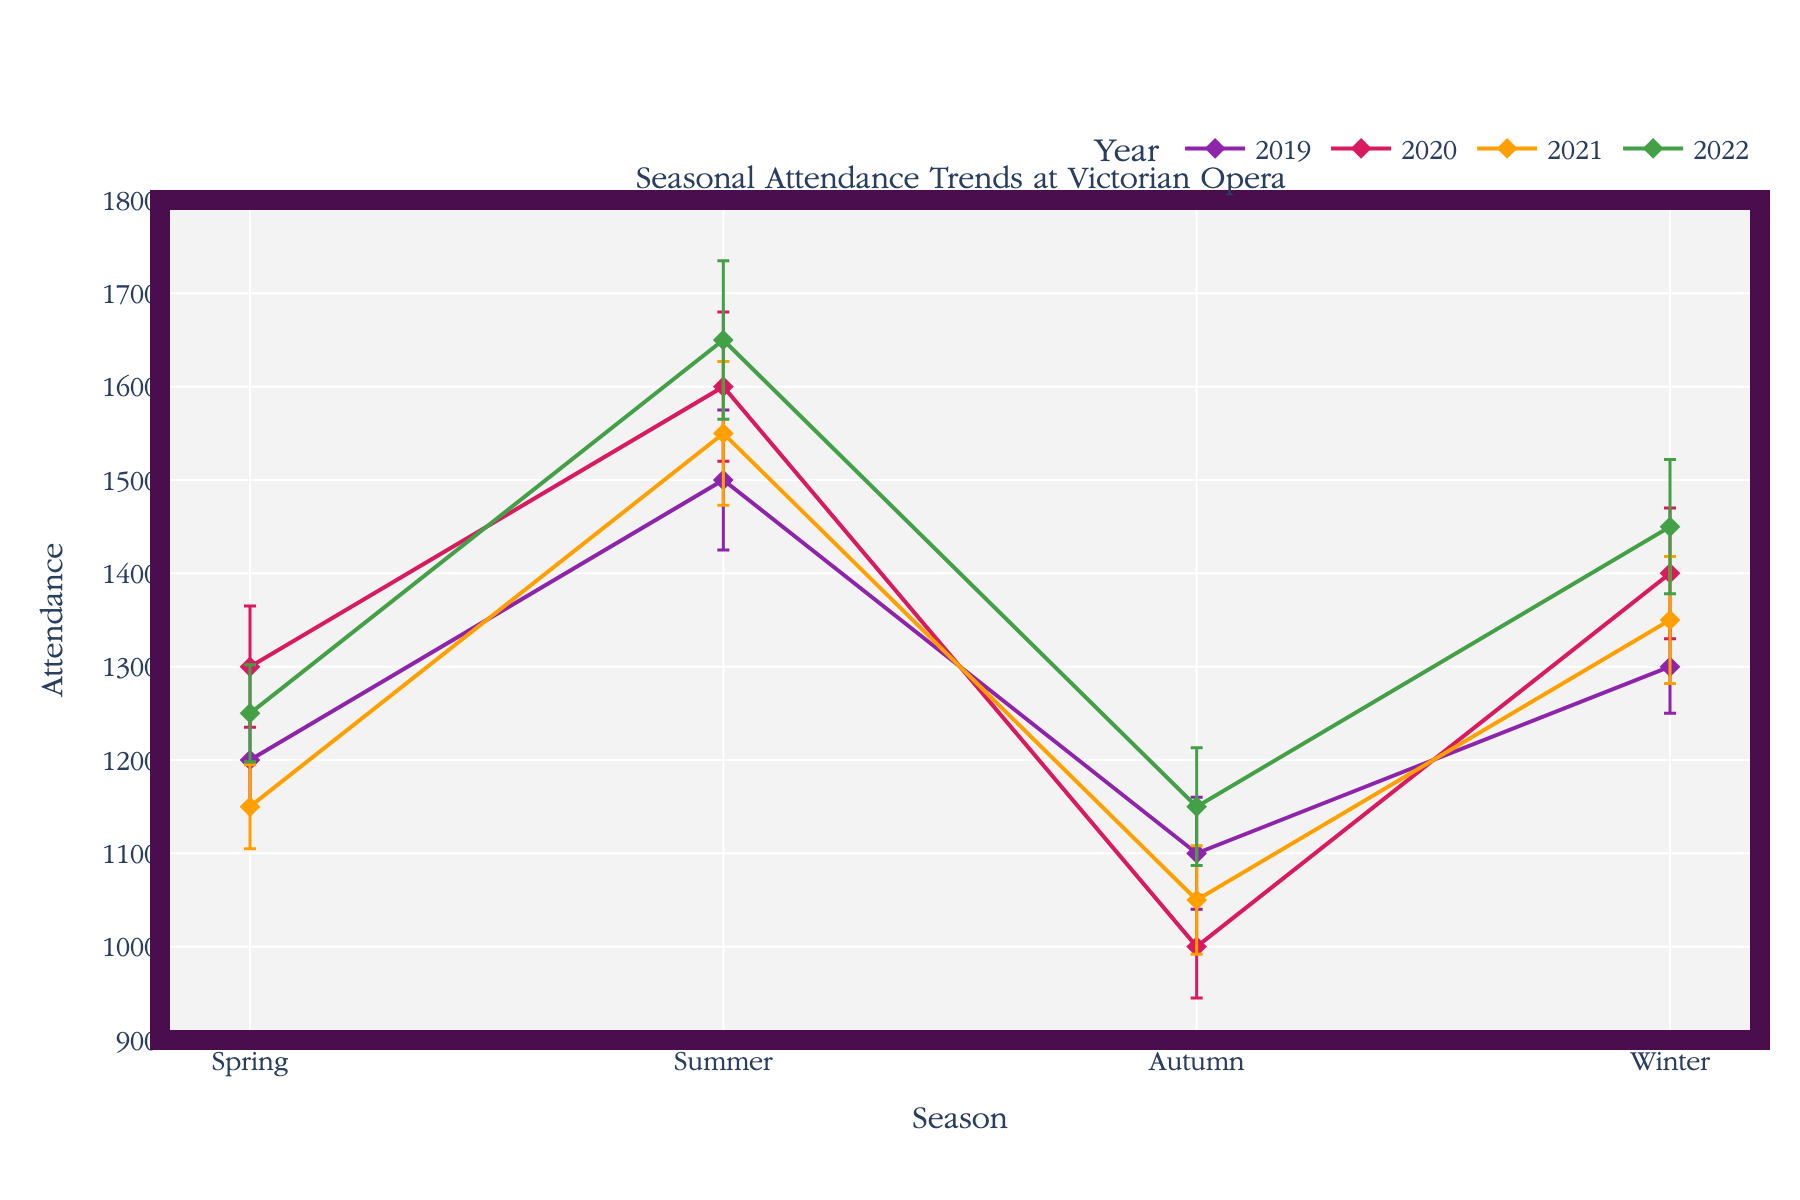What is the title of the plot? The title is at the top of the plot. It clearly states what the plot is about which helps to understand the context.
Answer: Seasonal Attendance Trends at Victorian Opera How many years are represented in the plot? Count the number of unique lines in different colors, each representing a different year.
Answer: 4 years Which year had the highest attendance during Winter? Look at the winter attendance data points for all years and identify the highest value.
Answer: 2022 What is the overall trend in attendance from Spring to Winter for the year 2020? Trace the attendance from Spring through Winter for 2020 and observe if it increases or decreases.
Answer: Increasing Which season shows the lowest variance in attendance over all years? Compare the variance error bars for each season across all years and find the smallest one.
Answer: Spring What is the difference in attendance between Summer 2022 and Summer 2019? Subtract the attendance of Summer 2019 from Summer 2022.
Answer: 150 Which year experienced the largest drop in attendance from Summer to Autumn? Calculate the drop (difference) in attendance from Summer to Autumn for each year and compare.
Answer: 2020 Considering all years, which season appears to have the most consistent attendance numbers? Evaluate the error bars for all seasons and see which has the smallest error bars over all years, indicating consistency.
Answer: Summer How does the attendance in Autumn 2021 compare to the attendance in Autumn 2020? Compare the two attendance values for Autumn 2020 and 2021 and see which is higher or lower.
Answer: Higher in 2021 What is the general trend for winter attendance over the years? Look at the winter data points for each year to determine if there's an increasing, decreasing, or stable trend.
Answer: Increasing 